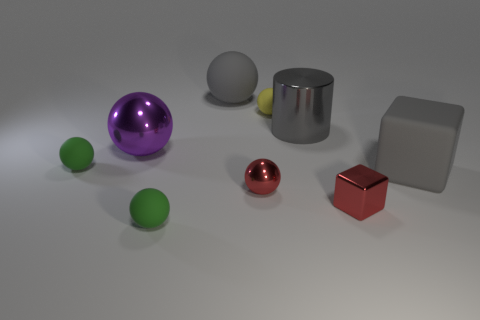How many green balls must be subtracted to get 1 green balls? 1 Subtract all tiny green spheres. How many spheres are left? 4 Subtract all brown cylinders. How many green spheres are left? 2 Subtract all yellow balls. How many balls are left? 5 Subtract all cylinders. How many objects are left? 8 Subtract 3 balls. How many balls are left? 3 Subtract 0 blue blocks. How many objects are left? 9 Subtract all green balls. Subtract all blue cylinders. How many balls are left? 4 Subtract all small shiny blocks. Subtract all tiny green rubber objects. How many objects are left? 6 Add 1 large shiny balls. How many large shiny balls are left? 2 